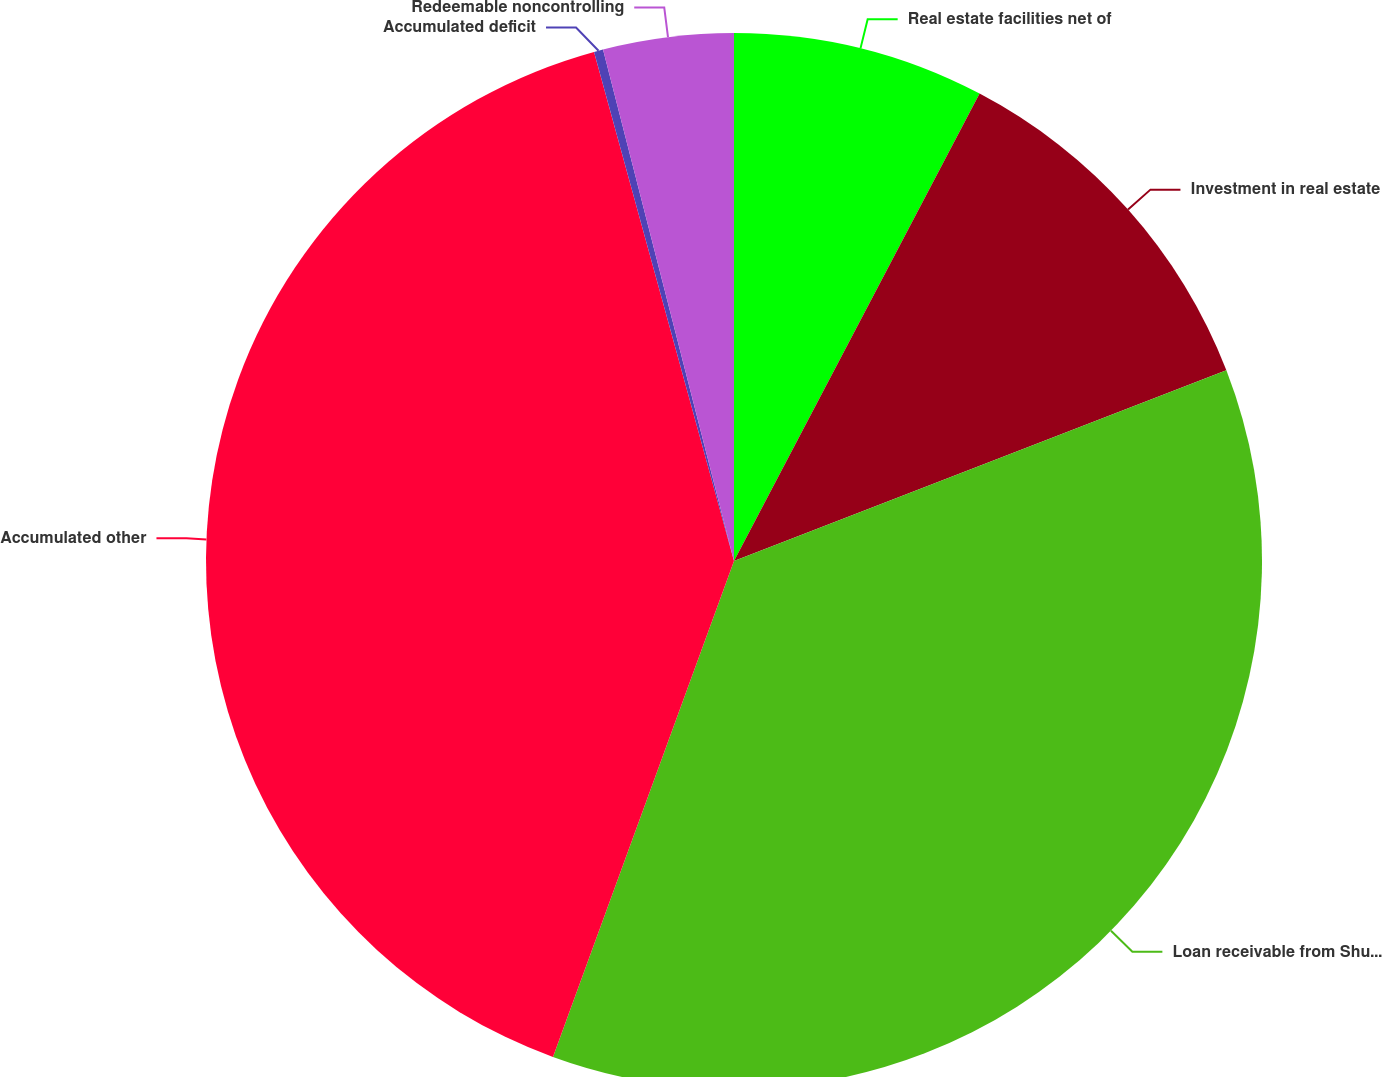Convert chart to OTSL. <chart><loc_0><loc_0><loc_500><loc_500><pie_chart><fcel>Real estate facilities net of<fcel>Investment in real estate<fcel>Loan receivable from Shurgard<fcel>Accumulated other<fcel>Accumulated deficit<fcel>Redeemable noncontrolling<nl><fcel>7.7%<fcel>11.42%<fcel>36.45%<fcel>40.16%<fcel>0.28%<fcel>3.99%<nl></chart> 